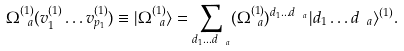Convert formula to latex. <formula><loc_0><loc_0><loc_500><loc_500>\Omega ^ { ( 1 ) } _ { \ a } ( v _ { 1 } ^ { ( 1 ) } \dots v _ { p _ { 1 } } ^ { ( 1 ) } ) \equiv | \Omega ^ { ( 1 ) } _ { \ a } \rangle = \sum _ { d _ { 1 } \dots d _ { \ a } } ( \Omega ^ { ( 1 ) } _ { \ a } ) ^ { d _ { 1 } \dots d _ { \ a } } | d _ { 1 } \dots d _ { \ a } \rangle ^ { ( 1 ) } .</formula> 